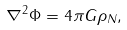<formula> <loc_0><loc_0><loc_500><loc_500>\nabla ^ { 2 } \Phi = 4 \pi G \rho _ { N } ,</formula> 